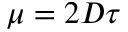<formula> <loc_0><loc_0><loc_500><loc_500>\mu = 2 D \tau</formula> 